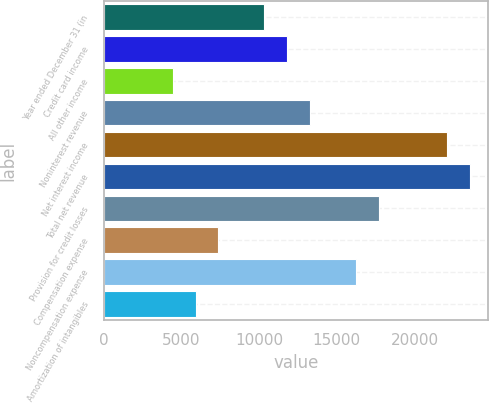Convert chart to OTSL. <chart><loc_0><loc_0><loc_500><loc_500><bar_chart><fcel>Year ended December 31 (in<fcel>Credit card income<fcel>All other income<fcel>Noninterest revenue<fcel>Net interest income<fcel>Total net revenue<fcel>Provision for credit losses<fcel>Compensation expense<fcel>Noncompensation expense<fcel>Amortization of intangibles<nl><fcel>10328.4<fcel>11800.6<fcel>4439.6<fcel>13272.8<fcel>22106<fcel>23578.2<fcel>17689.4<fcel>7384<fcel>16217.2<fcel>5911.8<nl></chart> 